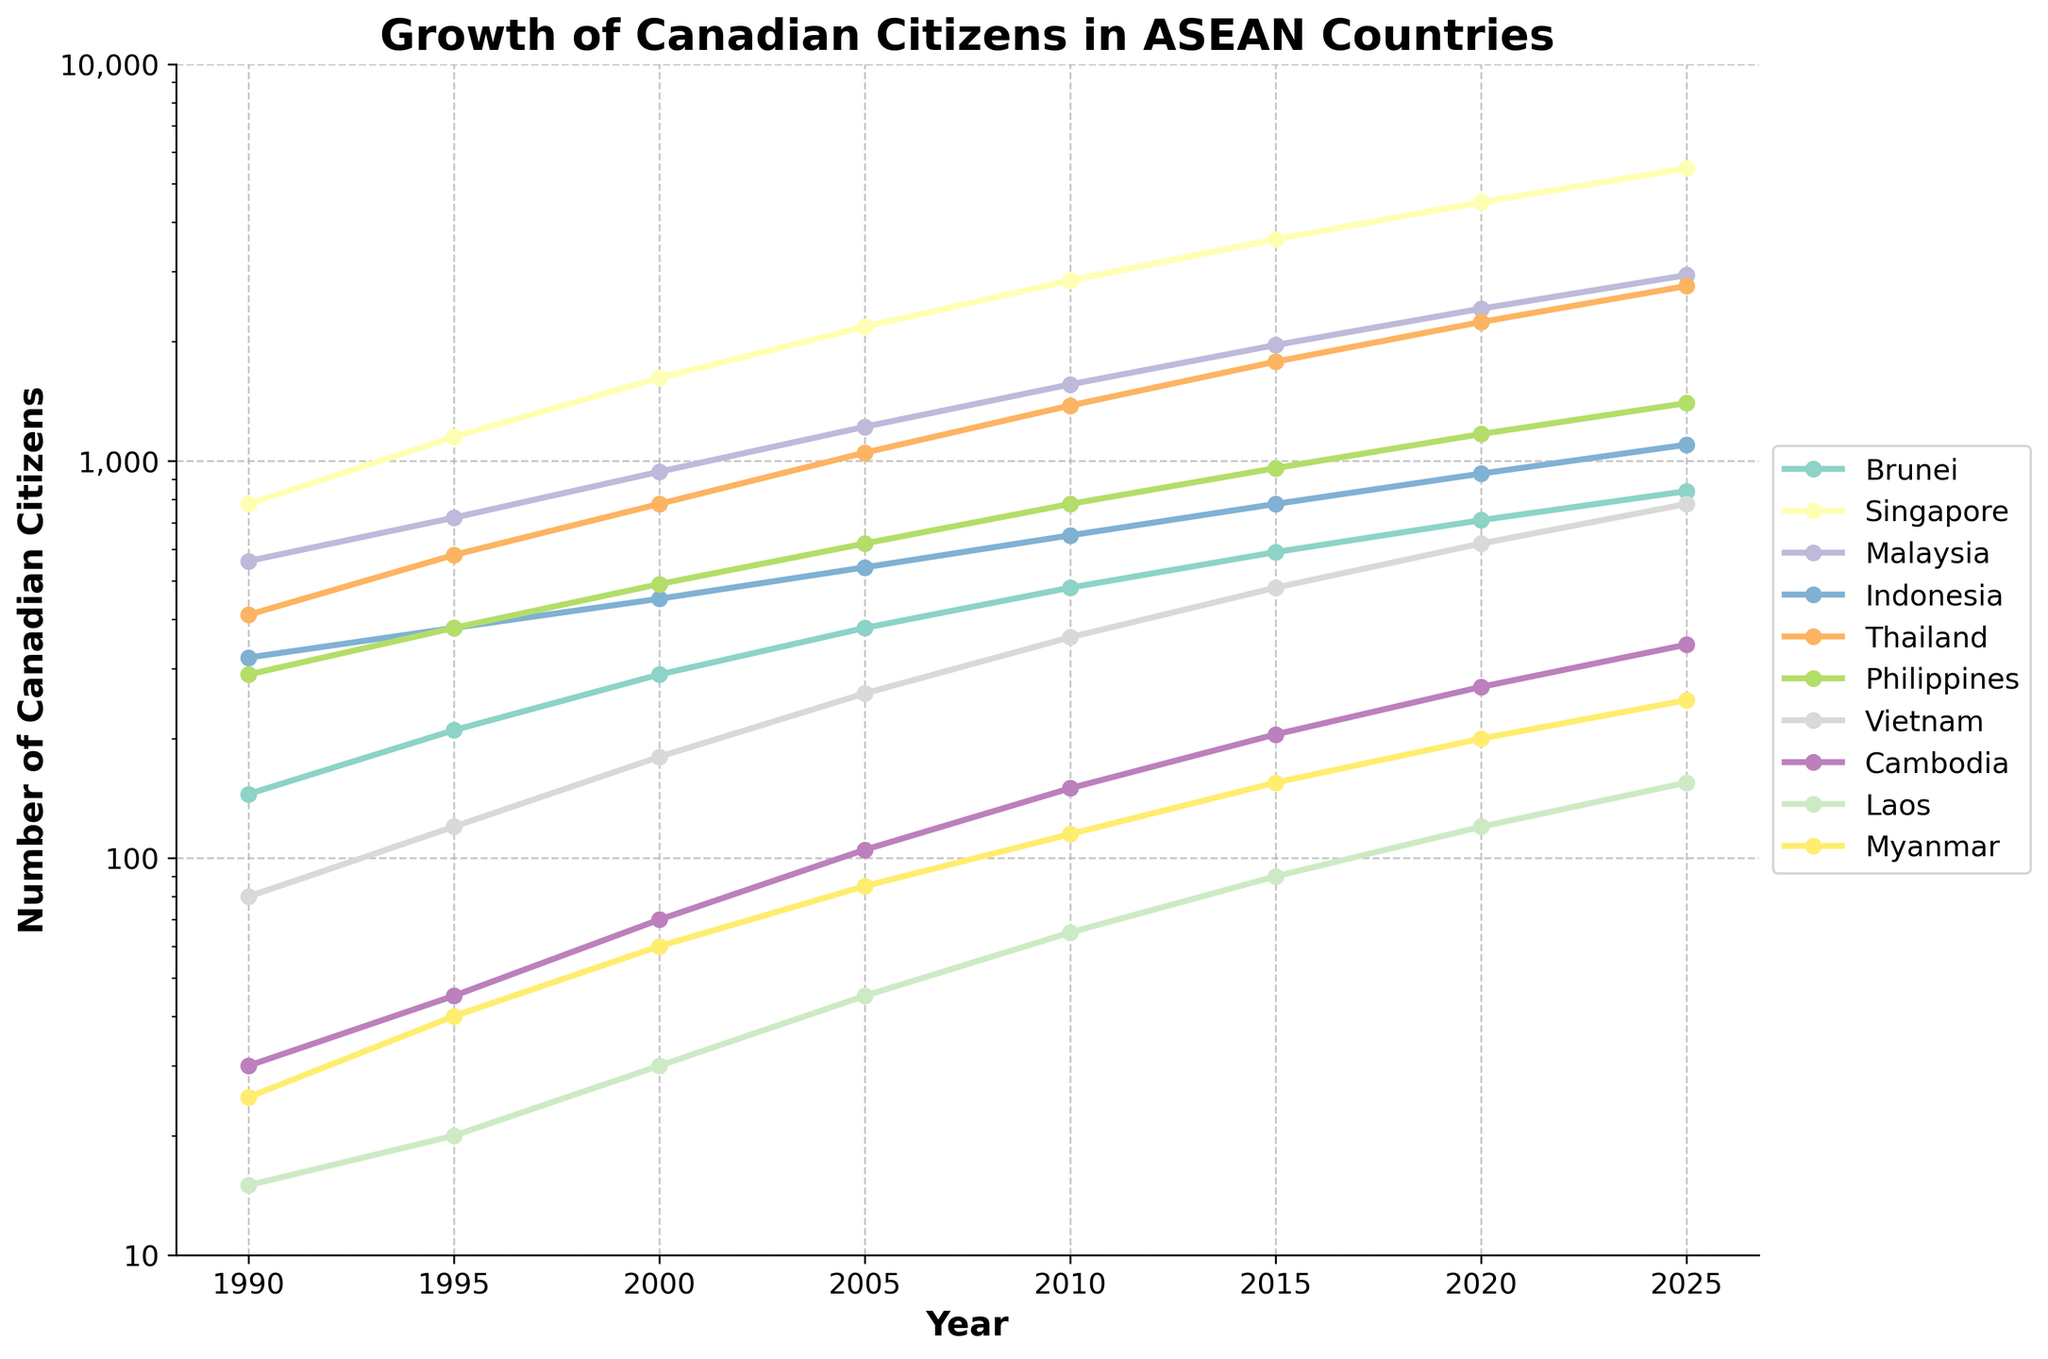What has been the general trend for the number of Canadian citizens living in ASEAN countries from 1990 to 2025? By observing the line chart, you can see that the numbers for each country have generally increased over time. The lines show an upward trend for all countries, indicating overall growth in the number of Canadian citizens living in ASEAN countries.
Answer: Increased Which country has the highest number of Canadian citizens living abroad as of 2025? By looking at the endpoint of the lines on the chart for the year 2025, Singapore has the highest number of Canadian citizens living abroad, as its line is at the highest position.
Answer: Singapore How many more Canadian citizens lived in Thailand compared to Malaysia in 2000? Find the points for Thailand and Malaysia on the chart in the year 2000. Thailand had 780, and Malaysia had 940. Subtract the number of Malaysian-based citizens from Thailand: 780 - 940 = -160. Thus, fewer Canadians lived in Thailand by 160.
Answer: 160 fewer In which year did Vietnam surpass 500 Canadian citizens living abroad? Track the line corresponding to Vietnam and observe when it crosses the 500 mark. It exceeds 500 between 2005 and 2010. Thus, by 2010, Vietnam had surpassed 500 Canadian citizens.
Answer: 2010 What has been the percentage growth of Canadian citizens in Brunei from 1990 to 2025? Identify the number of Canadians in Brunei in 1990 (145) and 2025 (840). Calculate the percentage growth: ((840 - 145) / 145) * 100 = 479.31%.
Answer: 479.31% Between 2005 and 2015, which country saw the greatest absolute increase in the number of Canadian citizens? Check the values for each country in 2005 and 2015. Calculate the differences: Brunei: 590-380=210, Singapore: 3620-2180=1440, Malaysia: 1960-1220=740, Indonesia: 780-540=240, Thailand: 1780-1050=730, Philippines: 960-620=340, Vietnam: 480-260=220, Cambodia: 205-105=100, Laos: 90-45=45, Myanmar: 155-85=70. Singapore has the highest increase of 1440.
Answer: Singapore What year shows the most significant dip or spike in the trend for the Philippines? Observe the line representing the Philippines. There is no significant dip, but the 1995-2025 interval shows a steady increase, highlighting gradual growth without prominent spikes or dips.
Answer: No significant dip or spike, steady increase How does the number of Canadian citizens in Myanmar in 2025 compare to those in Laos? Look at the figures for Myanmar (250) and Laos (155) in 2025. Myanmar has more Canadian citizens than Laos.
Answer: Myanmar Which country experienced the slowest growth rate from 1990 to 2025? By observing the slopes of the lines, the slowest growth can be deduced. Cambodia had small increments over the years, which seems the least substantial in comparison.
Answer: Cambodia Around what year did Cambodia have fewer than 100 Canadian citizens? Follow the line for Cambodia and locate where it crosses the number 100. Cambodia had fewer than 100 Canadian citizens until between 2005 and 2010.
Answer: Between 2005 and 2010 